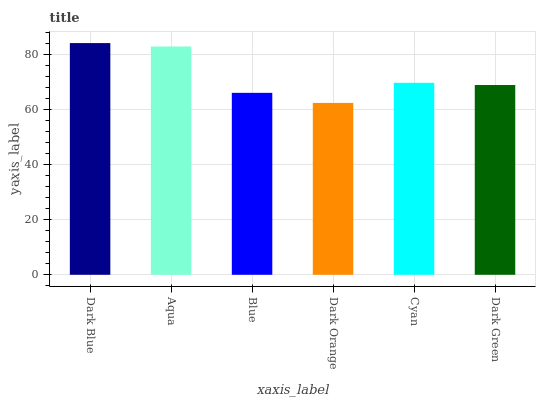Is Dark Blue the maximum?
Answer yes or no. Yes. Is Aqua the minimum?
Answer yes or no. No. Is Aqua the maximum?
Answer yes or no. No. Is Dark Blue greater than Aqua?
Answer yes or no. Yes. Is Aqua less than Dark Blue?
Answer yes or no. Yes. Is Aqua greater than Dark Blue?
Answer yes or no. No. Is Dark Blue less than Aqua?
Answer yes or no. No. Is Cyan the high median?
Answer yes or no. Yes. Is Dark Green the low median?
Answer yes or no. Yes. Is Dark Green the high median?
Answer yes or no. No. Is Blue the low median?
Answer yes or no. No. 